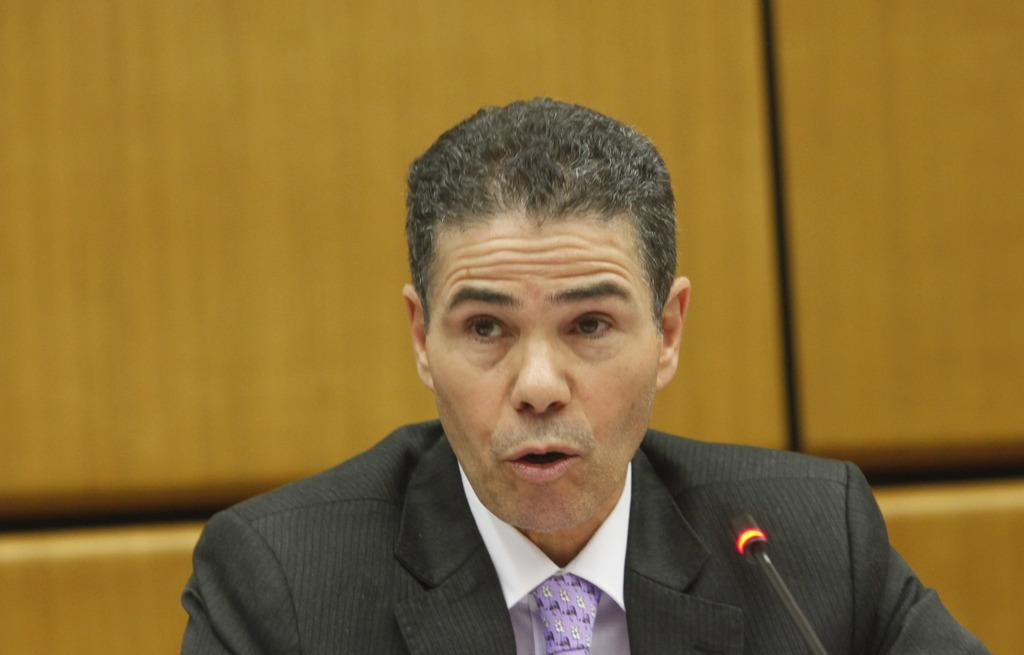Who or what is the main subject in the image? There is a person in the image. What is the person wearing? The person is wearing a black suit. What object is in front of the person? There is a microphone (mike) in front of the person. What is the weight of the bun on the person's head in the image? There is no bun present on the person's head in the image. How does the person use the skate to communicate with the audience? There is no skate present in the image; the person is using a microphone to communicate. 